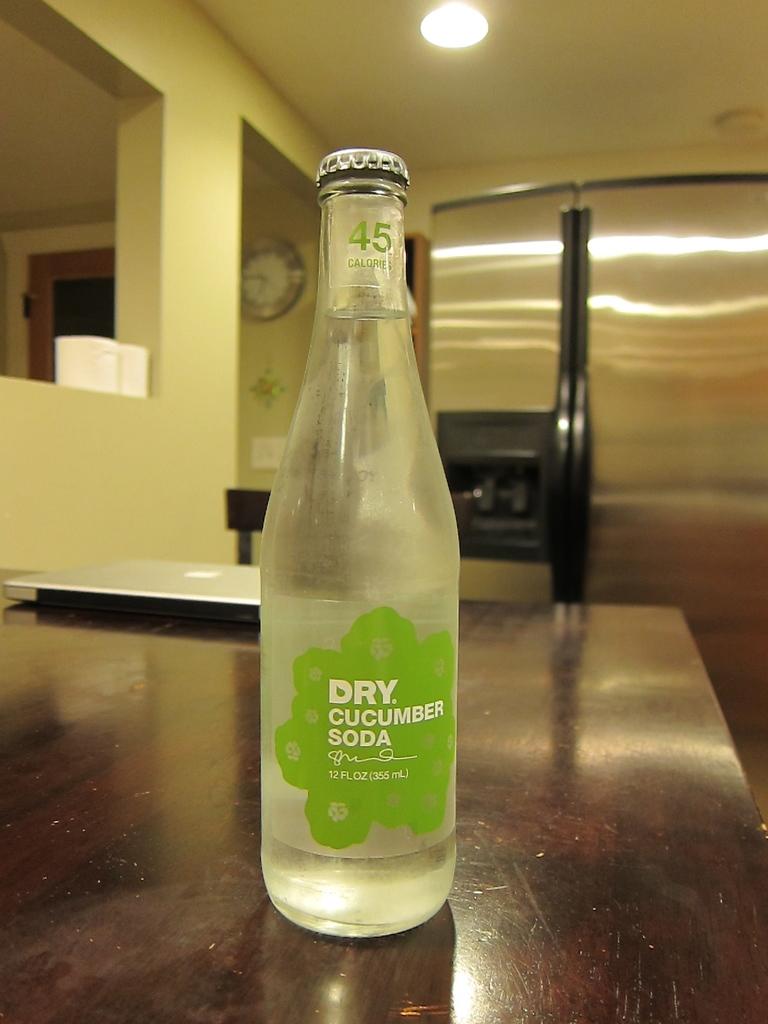What flavor of soda is this?
Offer a very short reply. Dry cucumber. How many calories does this soda have?
Your response must be concise. 45. 